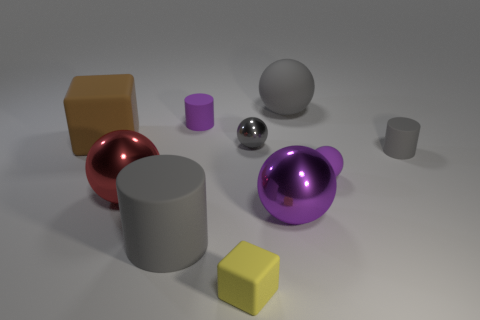Subtract all small cylinders. How many cylinders are left? 1 Subtract 2 balls. How many balls are left? 3 Subtract all gray balls. How many balls are left? 3 Add 6 big gray rubber balls. How many big gray rubber balls are left? 7 Add 5 small cylinders. How many small cylinders exist? 7 Subtract 0 yellow spheres. How many objects are left? 10 Subtract all cylinders. How many objects are left? 7 Subtract all yellow cylinders. Subtract all red blocks. How many cylinders are left? 3 Subtract all gray cylinders. How many yellow spheres are left? 0 Subtract all big gray cylinders. Subtract all large matte blocks. How many objects are left? 8 